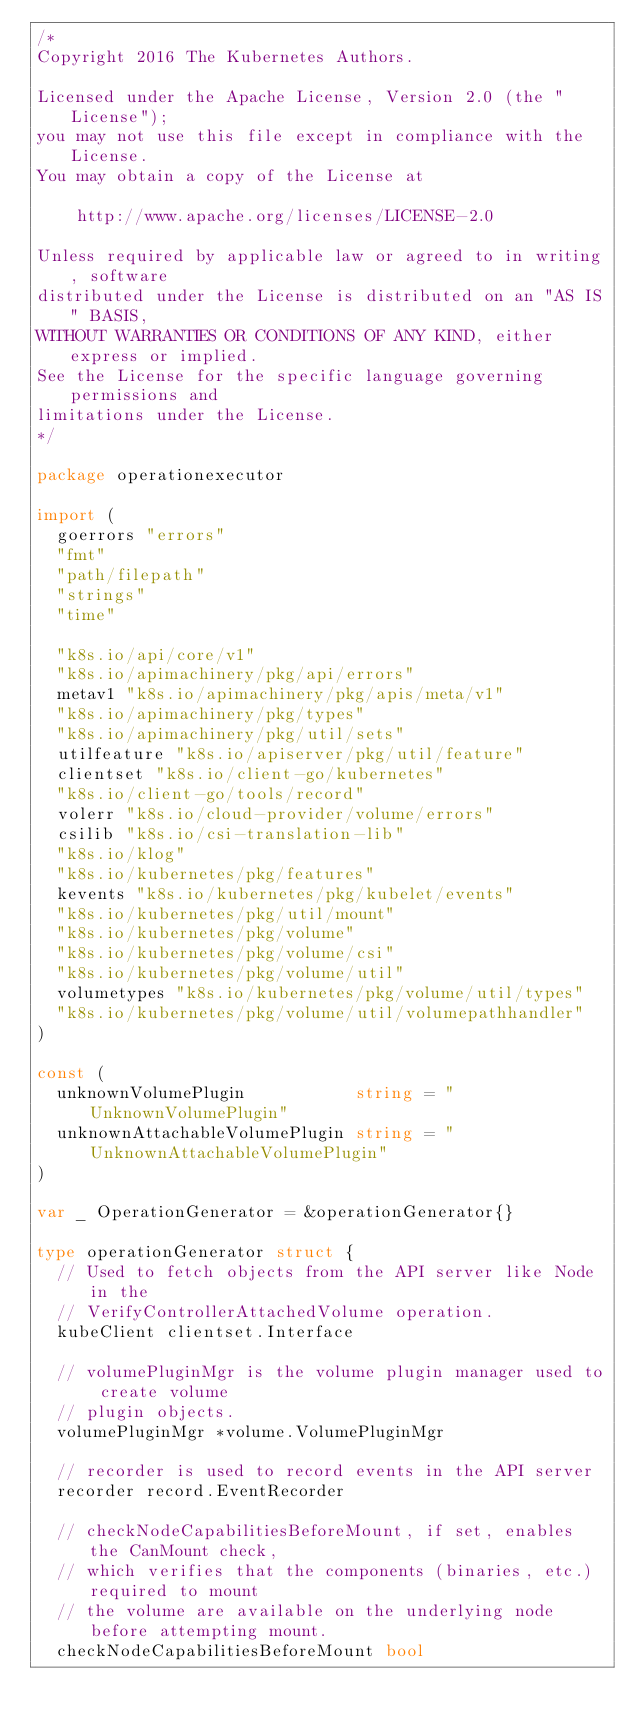<code> <loc_0><loc_0><loc_500><loc_500><_Go_>/*
Copyright 2016 The Kubernetes Authors.

Licensed under the Apache License, Version 2.0 (the "License");
you may not use this file except in compliance with the License.
You may obtain a copy of the License at

    http://www.apache.org/licenses/LICENSE-2.0

Unless required by applicable law or agreed to in writing, software
distributed under the License is distributed on an "AS IS" BASIS,
WITHOUT WARRANTIES OR CONDITIONS OF ANY KIND, either express or implied.
See the License for the specific language governing permissions and
limitations under the License.
*/

package operationexecutor

import (
	goerrors "errors"
	"fmt"
	"path/filepath"
	"strings"
	"time"

	"k8s.io/api/core/v1"
	"k8s.io/apimachinery/pkg/api/errors"
	metav1 "k8s.io/apimachinery/pkg/apis/meta/v1"
	"k8s.io/apimachinery/pkg/types"
	"k8s.io/apimachinery/pkg/util/sets"
	utilfeature "k8s.io/apiserver/pkg/util/feature"
	clientset "k8s.io/client-go/kubernetes"
	"k8s.io/client-go/tools/record"
	volerr "k8s.io/cloud-provider/volume/errors"
	csilib "k8s.io/csi-translation-lib"
	"k8s.io/klog"
	"k8s.io/kubernetes/pkg/features"
	kevents "k8s.io/kubernetes/pkg/kubelet/events"
	"k8s.io/kubernetes/pkg/util/mount"
	"k8s.io/kubernetes/pkg/volume"
	"k8s.io/kubernetes/pkg/volume/csi"
	"k8s.io/kubernetes/pkg/volume/util"
	volumetypes "k8s.io/kubernetes/pkg/volume/util/types"
	"k8s.io/kubernetes/pkg/volume/util/volumepathhandler"
)

const (
	unknownVolumePlugin           string = "UnknownVolumePlugin"
	unknownAttachableVolumePlugin string = "UnknownAttachableVolumePlugin"
)

var _ OperationGenerator = &operationGenerator{}

type operationGenerator struct {
	// Used to fetch objects from the API server like Node in the
	// VerifyControllerAttachedVolume operation.
	kubeClient clientset.Interface

	// volumePluginMgr is the volume plugin manager used to create volume
	// plugin objects.
	volumePluginMgr *volume.VolumePluginMgr

	// recorder is used to record events in the API server
	recorder record.EventRecorder

	// checkNodeCapabilitiesBeforeMount, if set, enables the CanMount check,
	// which verifies that the components (binaries, etc.) required to mount
	// the volume are available on the underlying node before attempting mount.
	checkNodeCapabilitiesBeforeMount bool
</code> 